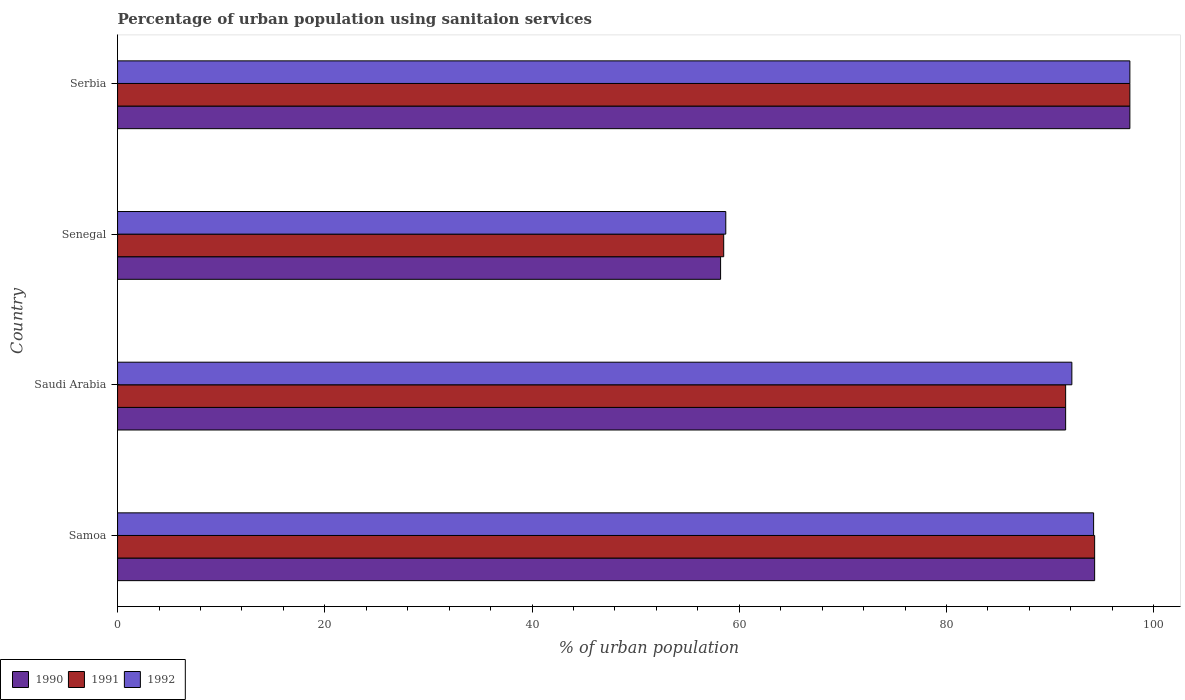How many groups of bars are there?
Your answer should be compact. 4. Are the number of bars on each tick of the Y-axis equal?
Offer a terse response. Yes. How many bars are there on the 3rd tick from the top?
Provide a short and direct response. 3. How many bars are there on the 3rd tick from the bottom?
Ensure brevity in your answer.  3. What is the label of the 2nd group of bars from the top?
Ensure brevity in your answer.  Senegal. What is the percentage of urban population using sanitaion services in 1990 in Saudi Arabia?
Give a very brief answer. 91.5. Across all countries, what is the maximum percentage of urban population using sanitaion services in 1991?
Keep it short and to the point. 97.7. Across all countries, what is the minimum percentage of urban population using sanitaion services in 1990?
Provide a short and direct response. 58.2. In which country was the percentage of urban population using sanitaion services in 1992 maximum?
Give a very brief answer. Serbia. In which country was the percentage of urban population using sanitaion services in 1990 minimum?
Give a very brief answer. Senegal. What is the total percentage of urban population using sanitaion services in 1990 in the graph?
Give a very brief answer. 341.7. What is the difference between the percentage of urban population using sanitaion services in 1990 in Samoa and that in Saudi Arabia?
Your answer should be compact. 2.8. What is the average percentage of urban population using sanitaion services in 1991 per country?
Ensure brevity in your answer.  85.5. What is the ratio of the percentage of urban population using sanitaion services in 1991 in Saudi Arabia to that in Senegal?
Keep it short and to the point. 1.56. Is the percentage of urban population using sanitaion services in 1991 in Senegal less than that in Serbia?
Keep it short and to the point. Yes. What is the difference between the highest and the second highest percentage of urban population using sanitaion services in 1991?
Your answer should be compact. 3.4. What is the difference between the highest and the lowest percentage of urban population using sanitaion services in 1991?
Ensure brevity in your answer.  39.2. Is the sum of the percentage of urban population using sanitaion services in 1990 in Samoa and Senegal greater than the maximum percentage of urban population using sanitaion services in 1991 across all countries?
Your response must be concise. Yes. What does the 3rd bar from the top in Saudi Arabia represents?
Your answer should be compact. 1990. What does the 3rd bar from the bottom in Senegal represents?
Your answer should be compact. 1992. How many bars are there?
Offer a very short reply. 12. What is the difference between two consecutive major ticks on the X-axis?
Ensure brevity in your answer.  20. Does the graph contain grids?
Offer a terse response. No. Where does the legend appear in the graph?
Ensure brevity in your answer.  Bottom left. How many legend labels are there?
Your answer should be compact. 3. What is the title of the graph?
Keep it short and to the point. Percentage of urban population using sanitaion services. Does "2012" appear as one of the legend labels in the graph?
Offer a terse response. No. What is the label or title of the X-axis?
Offer a very short reply. % of urban population. What is the % of urban population of 1990 in Samoa?
Offer a very short reply. 94.3. What is the % of urban population of 1991 in Samoa?
Offer a terse response. 94.3. What is the % of urban population in 1992 in Samoa?
Ensure brevity in your answer.  94.2. What is the % of urban population of 1990 in Saudi Arabia?
Keep it short and to the point. 91.5. What is the % of urban population in 1991 in Saudi Arabia?
Your response must be concise. 91.5. What is the % of urban population of 1992 in Saudi Arabia?
Your answer should be very brief. 92.1. What is the % of urban population of 1990 in Senegal?
Your answer should be very brief. 58.2. What is the % of urban population in 1991 in Senegal?
Offer a terse response. 58.5. What is the % of urban population of 1992 in Senegal?
Provide a succinct answer. 58.7. What is the % of urban population in 1990 in Serbia?
Your response must be concise. 97.7. What is the % of urban population in 1991 in Serbia?
Your answer should be very brief. 97.7. What is the % of urban population in 1992 in Serbia?
Make the answer very short. 97.7. Across all countries, what is the maximum % of urban population of 1990?
Provide a short and direct response. 97.7. Across all countries, what is the maximum % of urban population of 1991?
Make the answer very short. 97.7. Across all countries, what is the maximum % of urban population of 1992?
Keep it short and to the point. 97.7. Across all countries, what is the minimum % of urban population in 1990?
Keep it short and to the point. 58.2. Across all countries, what is the minimum % of urban population of 1991?
Make the answer very short. 58.5. Across all countries, what is the minimum % of urban population in 1992?
Provide a succinct answer. 58.7. What is the total % of urban population of 1990 in the graph?
Keep it short and to the point. 341.7. What is the total % of urban population in 1991 in the graph?
Keep it short and to the point. 342. What is the total % of urban population of 1992 in the graph?
Ensure brevity in your answer.  342.7. What is the difference between the % of urban population of 1991 in Samoa and that in Saudi Arabia?
Make the answer very short. 2.8. What is the difference between the % of urban population in 1990 in Samoa and that in Senegal?
Make the answer very short. 36.1. What is the difference between the % of urban population of 1991 in Samoa and that in Senegal?
Make the answer very short. 35.8. What is the difference between the % of urban population in 1992 in Samoa and that in Senegal?
Your answer should be compact. 35.5. What is the difference between the % of urban population of 1990 in Samoa and that in Serbia?
Offer a terse response. -3.4. What is the difference between the % of urban population of 1991 in Samoa and that in Serbia?
Provide a short and direct response. -3.4. What is the difference between the % of urban population in 1992 in Samoa and that in Serbia?
Offer a very short reply. -3.5. What is the difference between the % of urban population of 1990 in Saudi Arabia and that in Senegal?
Make the answer very short. 33.3. What is the difference between the % of urban population of 1992 in Saudi Arabia and that in Senegal?
Ensure brevity in your answer.  33.4. What is the difference between the % of urban population of 1991 in Saudi Arabia and that in Serbia?
Your answer should be very brief. -6.2. What is the difference between the % of urban population of 1992 in Saudi Arabia and that in Serbia?
Provide a succinct answer. -5.6. What is the difference between the % of urban population of 1990 in Senegal and that in Serbia?
Keep it short and to the point. -39.5. What is the difference between the % of urban population in 1991 in Senegal and that in Serbia?
Provide a succinct answer. -39.2. What is the difference between the % of urban population of 1992 in Senegal and that in Serbia?
Your answer should be compact. -39. What is the difference between the % of urban population of 1990 in Samoa and the % of urban population of 1991 in Senegal?
Offer a terse response. 35.8. What is the difference between the % of urban population of 1990 in Samoa and the % of urban population of 1992 in Senegal?
Offer a very short reply. 35.6. What is the difference between the % of urban population of 1991 in Samoa and the % of urban population of 1992 in Senegal?
Provide a short and direct response. 35.6. What is the difference between the % of urban population in 1990 in Samoa and the % of urban population in 1991 in Serbia?
Provide a succinct answer. -3.4. What is the difference between the % of urban population in 1990 in Samoa and the % of urban population in 1992 in Serbia?
Make the answer very short. -3.4. What is the difference between the % of urban population in 1991 in Samoa and the % of urban population in 1992 in Serbia?
Provide a short and direct response. -3.4. What is the difference between the % of urban population of 1990 in Saudi Arabia and the % of urban population of 1991 in Senegal?
Your response must be concise. 33. What is the difference between the % of urban population of 1990 in Saudi Arabia and the % of urban population of 1992 in Senegal?
Offer a terse response. 32.8. What is the difference between the % of urban population of 1991 in Saudi Arabia and the % of urban population of 1992 in Senegal?
Offer a very short reply. 32.8. What is the difference between the % of urban population of 1991 in Saudi Arabia and the % of urban population of 1992 in Serbia?
Offer a terse response. -6.2. What is the difference between the % of urban population in 1990 in Senegal and the % of urban population in 1991 in Serbia?
Your response must be concise. -39.5. What is the difference between the % of urban population in 1990 in Senegal and the % of urban population in 1992 in Serbia?
Offer a very short reply. -39.5. What is the difference between the % of urban population in 1991 in Senegal and the % of urban population in 1992 in Serbia?
Offer a very short reply. -39.2. What is the average % of urban population in 1990 per country?
Offer a very short reply. 85.42. What is the average % of urban population in 1991 per country?
Offer a terse response. 85.5. What is the average % of urban population in 1992 per country?
Make the answer very short. 85.67. What is the difference between the % of urban population in 1990 and % of urban population in 1991 in Samoa?
Offer a very short reply. 0. What is the difference between the % of urban population of 1990 and % of urban population of 1991 in Saudi Arabia?
Offer a terse response. 0. What is the difference between the % of urban population of 1990 and % of urban population of 1992 in Saudi Arabia?
Your response must be concise. -0.6. What is the difference between the % of urban population in 1990 and % of urban population in 1991 in Senegal?
Offer a very short reply. -0.3. What is the difference between the % of urban population of 1990 and % of urban population of 1991 in Serbia?
Provide a short and direct response. 0. What is the difference between the % of urban population of 1990 and % of urban population of 1992 in Serbia?
Give a very brief answer. 0. What is the difference between the % of urban population of 1991 and % of urban population of 1992 in Serbia?
Your answer should be very brief. 0. What is the ratio of the % of urban population of 1990 in Samoa to that in Saudi Arabia?
Offer a terse response. 1.03. What is the ratio of the % of urban population in 1991 in Samoa to that in Saudi Arabia?
Provide a short and direct response. 1.03. What is the ratio of the % of urban population of 1992 in Samoa to that in Saudi Arabia?
Offer a very short reply. 1.02. What is the ratio of the % of urban population in 1990 in Samoa to that in Senegal?
Your response must be concise. 1.62. What is the ratio of the % of urban population in 1991 in Samoa to that in Senegal?
Give a very brief answer. 1.61. What is the ratio of the % of urban population of 1992 in Samoa to that in Senegal?
Your answer should be very brief. 1.6. What is the ratio of the % of urban population of 1990 in Samoa to that in Serbia?
Ensure brevity in your answer.  0.97. What is the ratio of the % of urban population of 1991 in Samoa to that in Serbia?
Make the answer very short. 0.97. What is the ratio of the % of urban population of 1992 in Samoa to that in Serbia?
Your response must be concise. 0.96. What is the ratio of the % of urban population of 1990 in Saudi Arabia to that in Senegal?
Give a very brief answer. 1.57. What is the ratio of the % of urban population of 1991 in Saudi Arabia to that in Senegal?
Ensure brevity in your answer.  1.56. What is the ratio of the % of urban population in 1992 in Saudi Arabia to that in Senegal?
Your answer should be very brief. 1.57. What is the ratio of the % of urban population in 1990 in Saudi Arabia to that in Serbia?
Make the answer very short. 0.94. What is the ratio of the % of urban population of 1991 in Saudi Arabia to that in Serbia?
Provide a succinct answer. 0.94. What is the ratio of the % of urban population of 1992 in Saudi Arabia to that in Serbia?
Your answer should be very brief. 0.94. What is the ratio of the % of urban population in 1990 in Senegal to that in Serbia?
Your response must be concise. 0.6. What is the ratio of the % of urban population in 1991 in Senegal to that in Serbia?
Your response must be concise. 0.6. What is the ratio of the % of urban population of 1992 in Senegal to that in Serbia?
Your answer should be very brief. 0.6. What is the difference between the highest and the second highest % of urban population in 1991?
Your answer should be compact. 3.4. What is the difference between the highest and the lowest % of urban population in 1990?
Provide a succinct answer. 39.5. What is the difference between the highest and the lowest % of urban population of 1991?
Your response must be concise. 39.2. What is the difference between the highest and the lowest % of urban population of 1992?
Ensure brevity in your answer.  39. 